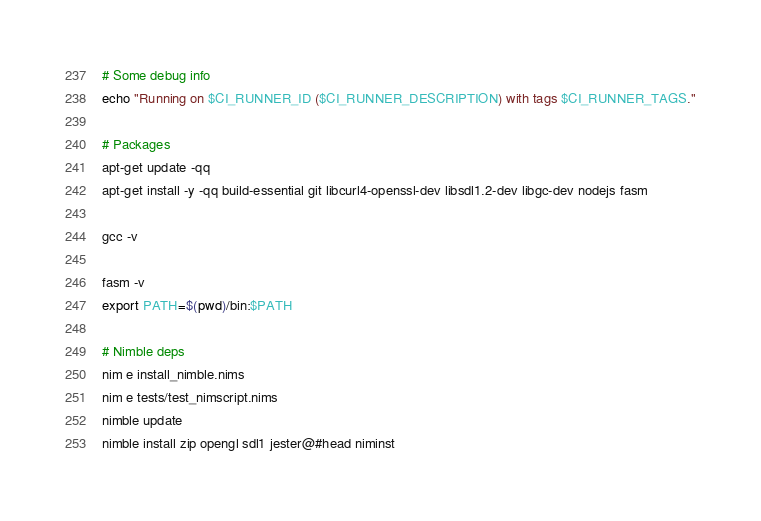Convert code to text. <code><loc_0><loc_0><loc_500><loc_500><_Bash_># Some debug info
echo "Running on $CI_RUNNER_ID ($CI_RUNNER_DESCRIPTION) with tags $CI_RUNNER_TAGS."

# Packages
apt-get update -qq
apt-get install -y -qq build-essential git libcurl4-openssl-dev libsdl1.2-dev libgc-dev nodejs fasm

gcc -v

fasm -v
export PATH=$(pwd)/bin:$PATH

# Nimble deps
nim e install_nimble.nims
nim e tests/test_nimscript.nims
nimble update
nimble install zip opengl sdl1 jester@#head niminst
</code> 